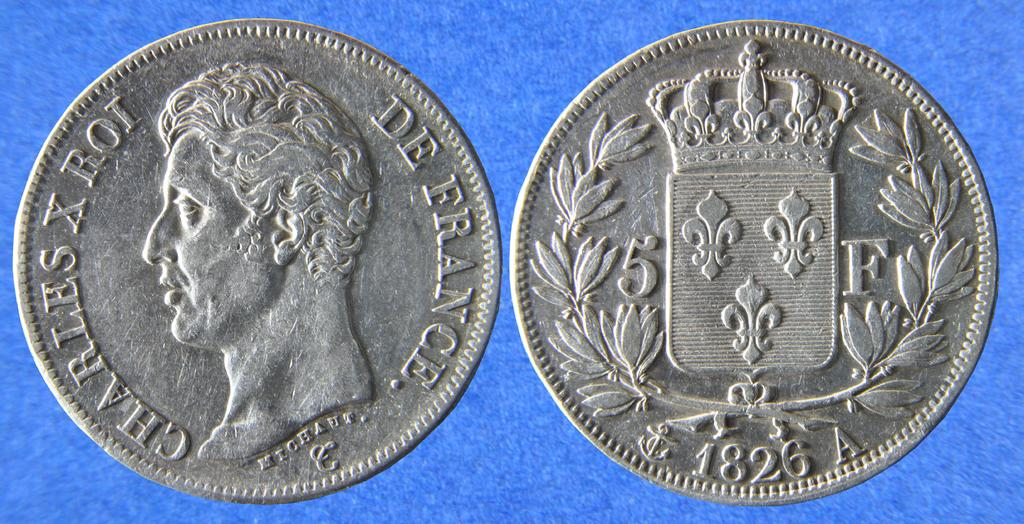<image>
Summarize the visual content of the image. a De France coin shown on front and back 